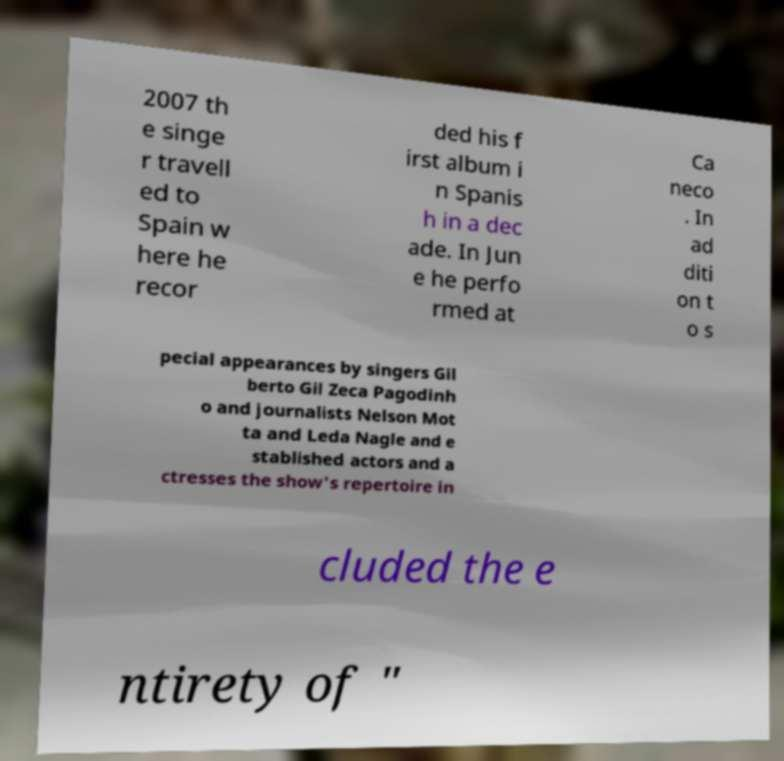Please identify and transcribe the text found in this image. 2007 th e singe r travell ed to Spain w here he recor ded his f irst album i n Spanis h in a dec ade. In Jun e he perfo rmed at Ca neco . In ad diti on t o s pecial appearances by singers Gil berto Gil Zeca Pagodinh o and journalists Nelson Mot ta and Leda Nagle and e stablished actors and a ctresses the show's repertoire in cluded the e ntirety of " 